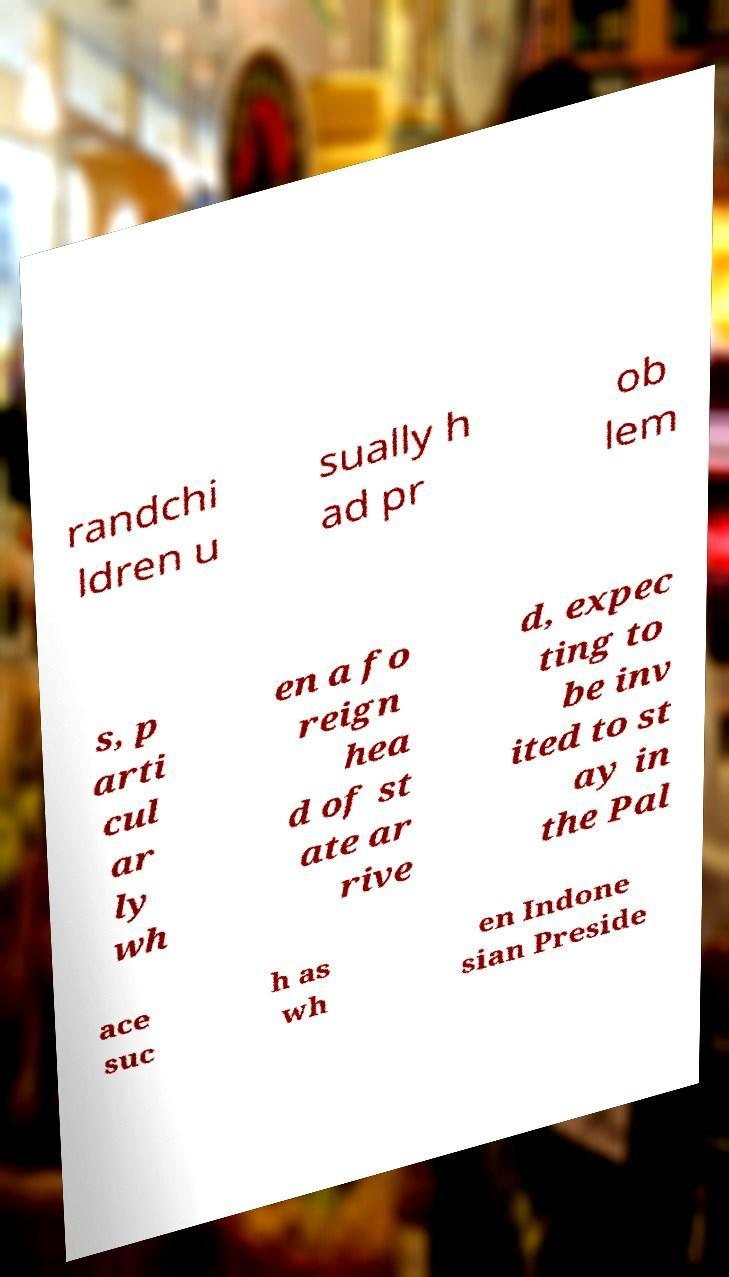Could you assist in decoding the text presented in this image and type it out clearly? randchi ldren u sually h ad pr ob lem s, p arti cul ar ly wh en a fo reign hea d of st ate ar rive d, expec ting to be inv ited to st ay in the Pal ace suc h as wh en Indone sian Preside 